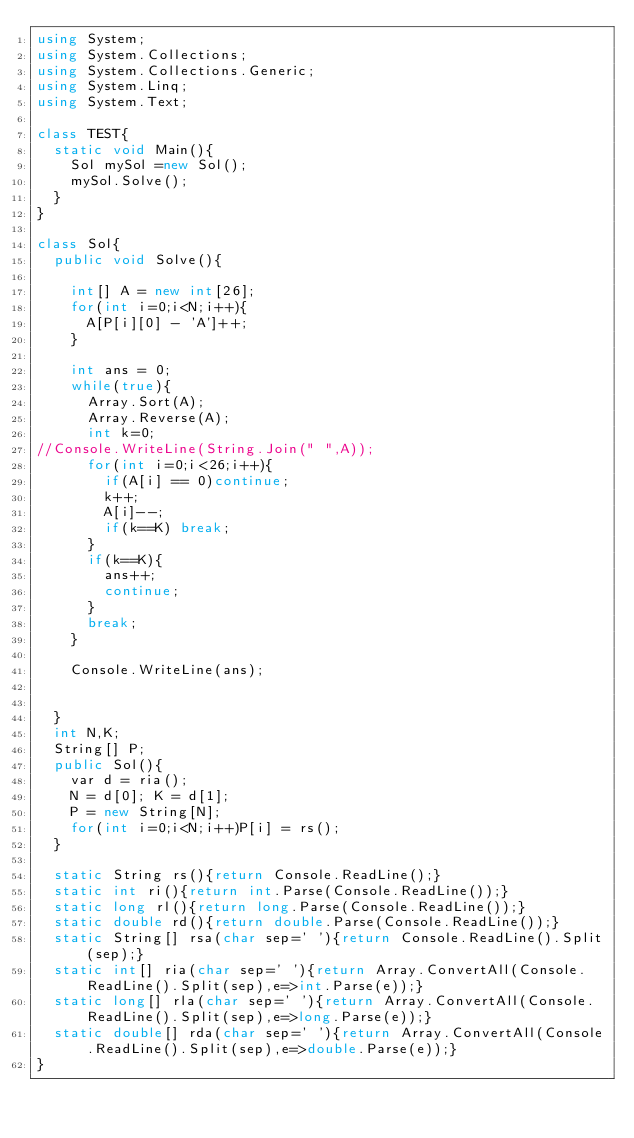<code> <loc_0><loc_0><loc_500><loc_500><_C#_>using System;
using System.Collections;
using System.Collections.Generic;
using System.Linq;
using System.Text;

class TEST{
	static void Main(){
		Sol mySol =new Sol();
		mySol.Solve();
	}
}

class Sol{
	public void Solve(){
		
		int[] A = new int[26];
		for(int i=0;i<N;i++){
			A[P[i][0] - 'A']++;
		}
		
		int ans = 0;
		while(true){
			Array.Sort(A);
			Array.Reverse(A);
			int k=0;
//Console.WriteLine(String.Join(" ",A));
			for(int i=0;i<26;i++){
				if(A[i] == 0)continue;
				k++;
				A[i]--;
				if(k==K) break;
			}
			if(k==K){
				ans++;
				continue;
			}
			break;
		}
		
		Console.WriteLine(ans);
		
		
	}
	int N,K;
	String[] P;
	public Sol(){
		var d = ria();
		N = d[0]; K = d[1];
		P = new String[N];
		for(int i=0;i<N;i++)P[i] = rs();
	}

	static String rs(){return Console.ReadLine();}
	static int ri(){return int.Parse(Console.ReadLine());}
	static long rl(){return long.Parse(Console.ReadLine());}
	static double rd(){return double.Parse(Console.ReadLine());}
	static String[] rsa(char sep=' '){return Console.ReadLine().Split(sep);}
	static int[] ria(char sep=' '){return Array.ConvertAll(Console.ReadLine().Split(sep),e=>int.Parse(e));}
	static long[] rla(char sep=' '){return Array.ConvertAll(Console.ReadLine().Split(sep),e=>long.Parse(e));}
	static double[] rda(char sep=' '){return Array.ConvertAll(Console.ReadLine().Split(sep),e=>double.Parse(e));}
}
</code> 